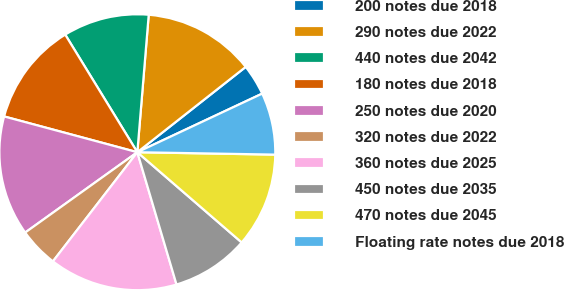Convert chart. <chart><loc_0><loc_0><loc_500><loc_500><pie_chart><fcel>200 notes due 2018<fcel>290 notes due 2022<fcel>440 notes due 2042<fcel>180 notes due 2018<fcel>250 notes due 2020<fcel>320 notes due 2022<fcel>360 notes due 2025<fcel>450 notes due 2035<fcel>470 notes due 2045<fcel>Floating rate notes due 2018<nl><fcel>3.63%<fcel>13.07%<fcel>10.07%<fcel>12.07%<fcel>14.07%<fcel>4.63%<fcel>15.06%<fcel>9.07%<fcel>11.07%<fcel>7.26%<nl></chart> 